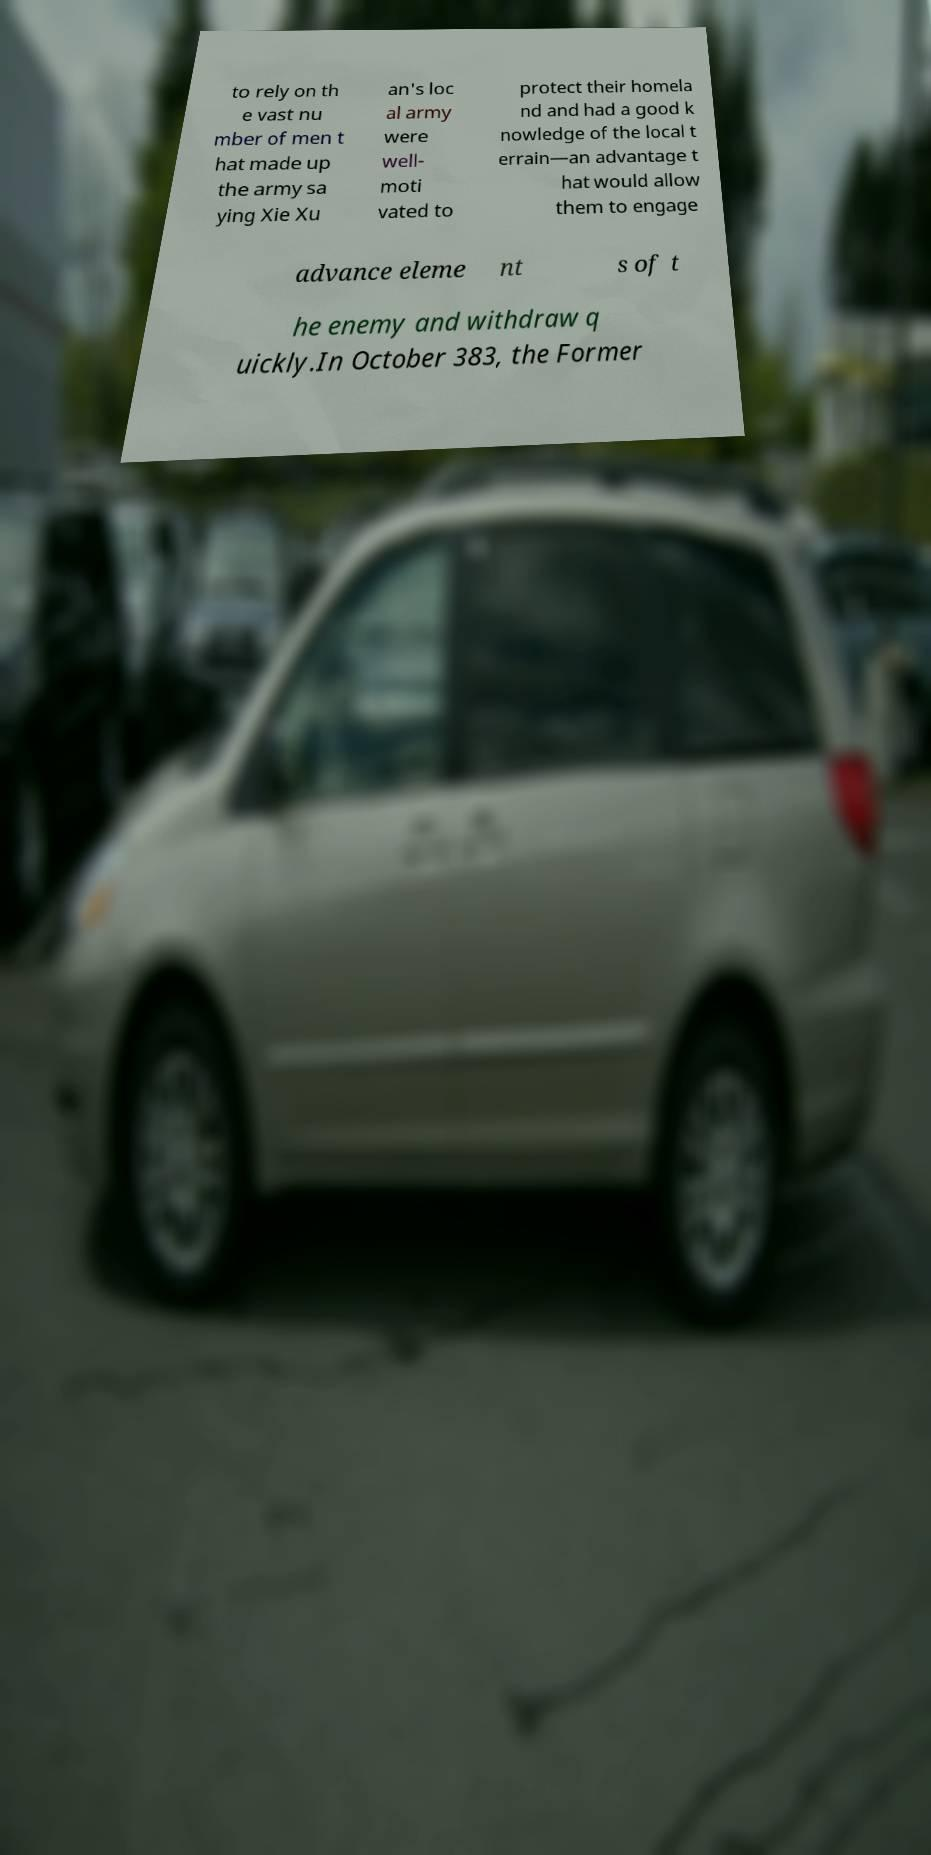Please read and relay the text visible in this image. What does it say? to rely on th e vast nu mber of men t hat made up the army sa ying Xie Xu an's loc al army were well- moti vated to protect their homela nd and had a good k nowledge of the local t errain—an advantage t hat would allow them to engage advance eleme nt s of t he enemy and withdraw q uickly.In October 383, the Former 